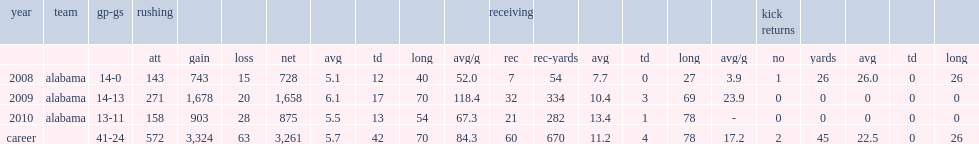In the 2009 season, how many receiving yards did ingram have? 334.0. 